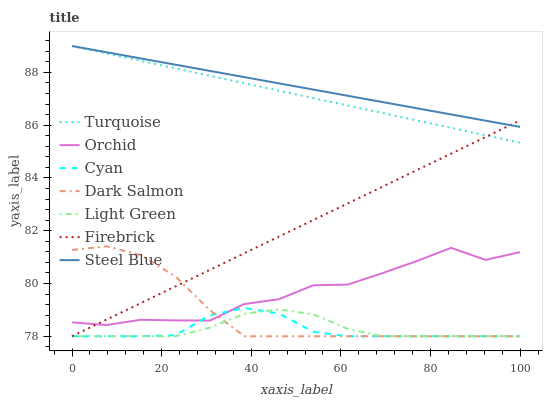Does Cyan have the minimum area under the curve?
Answer yes or no. Yes. Does Steel Blue have the maximum area under the curve?
Answer yes or no. Yes. Does Firebrick have the minimum area under the curve?
Answer yes or no. No. Does Firebrick have the maximum area under the curve?
Answer yes or no. No. Is Steel Blue the smoothest?
Answer yes or no. Yes. Is Orchid the roughest?
Answer yes or no. Yes. Is Firebrick the smoothest?
Answer yes or no. No. Is Firebrick the roughest?
Answer yes or no. No. Does Firebrick have the lowest value?
Answer yes or no. Yes. Does Steel Blue have the lowest value?
Answer yes or no. No. Does Steel Blue have the highest value?
Answer yes or no. Yes. Does Firebrick have the highest value?
Answer yes or no. No. Is Light Green less than Orchid?
Answer yes or no. Yes. Is Steel Blue greater than Light Green?
Answer yes or no. Yes. Does Orchid intersect Dark Salmon?
Answer yes or no. Yes. Is Orchid less than Dark Salmon?
Answer yes or no. No. Is Orchid greater than Dark Salmon?
Answer yes or no. No. Does Light Green intersect Orchid?
Answer yes or no. No. 